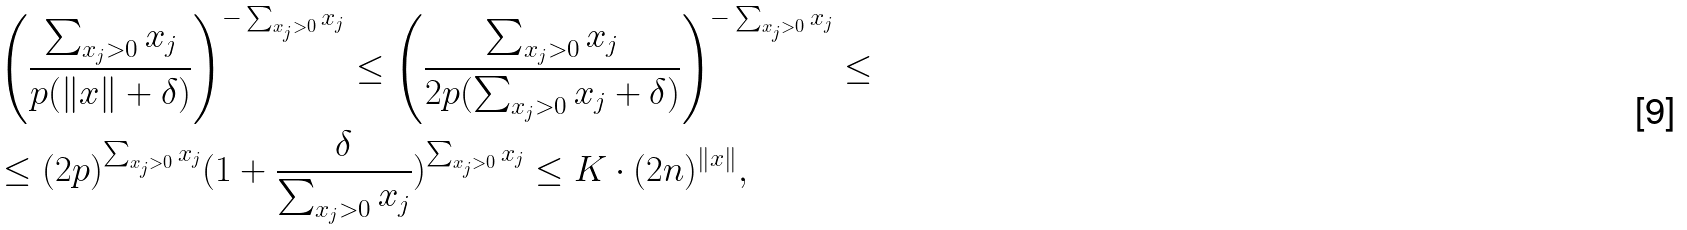Convert formula to latex. <formula><loc_0><loc_0><loc_500><loc_500>& \left ( \frac { \sum _ { x _ { j } > 0 } x _ { j } } { p ( \| x \| + \delta ) } \right ) ^ { - \sum _ { x _ { j } > 0 } x _ { j } } \leq \left ( \frac { \sum _ { x _ { j } > 0 } x _ { j } } { 2 p ( \sum _ { x _ { j } > 0 } x _ { j } + \delta ) } \right ) ^ { - \sum _ { x _ { j } > 0 } x _ { j } } \leq \\ & \leq ( 2 p ) ^ { \sum _ { x _ { j } > 0 } x _ { j } } ( 1 + \frac { \delta } { \sum _ { x _ { j } > 0 } x _ { j } } ) ^ { \sum _ { x _ { j } > 0 } x _ { j } } \leq K \cdot ( 2 n ) ^ { \| x \| } ,</formula> 